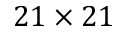Convert formula to latex. <formula><loc_0><loc_0><loc_500><loc_500>2 1 \times 2 1</formula> 